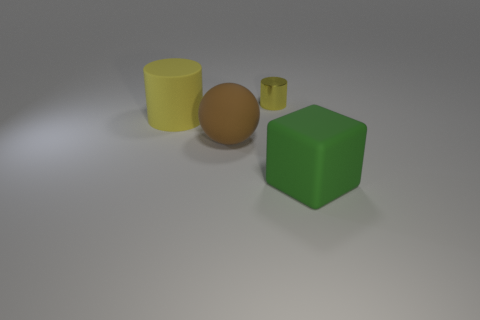What color is the large matte cube?
Offer a terse response. Green. How many other things are there of the same shape as the small yellow thing?
Provide a short and direct response. 1. Are there the same number of brown rubber things on the right side of the small metallic object and large objects right of the big matte sphere?
Keep it short and to the point. No. What is the small yellow cylinder made of?
Offer a terse response. Metal. What material is the yellow thing on the right side of the brown rubber sphere?
Your answer should be very brief. Metal. Is there anything else that has the same material as the tiny yellow thing?
Make the answer very short. No. Are there more things to the right of the yellow metal cylinder than red rubber cylinders?
Offer a very short reply. Yes. There is a large matte object that is to the right of the tiny metallic cylinder that is behind the matte cylinder; are there any cylinders behind it?
Your response must be concise. Yes. Are there any matte things on the left side of the green rubber object?
Provide a succinct answer. Yes. What number of blocks have the same color as the small metal cylinder?
Your answer should be very brief. 0. 